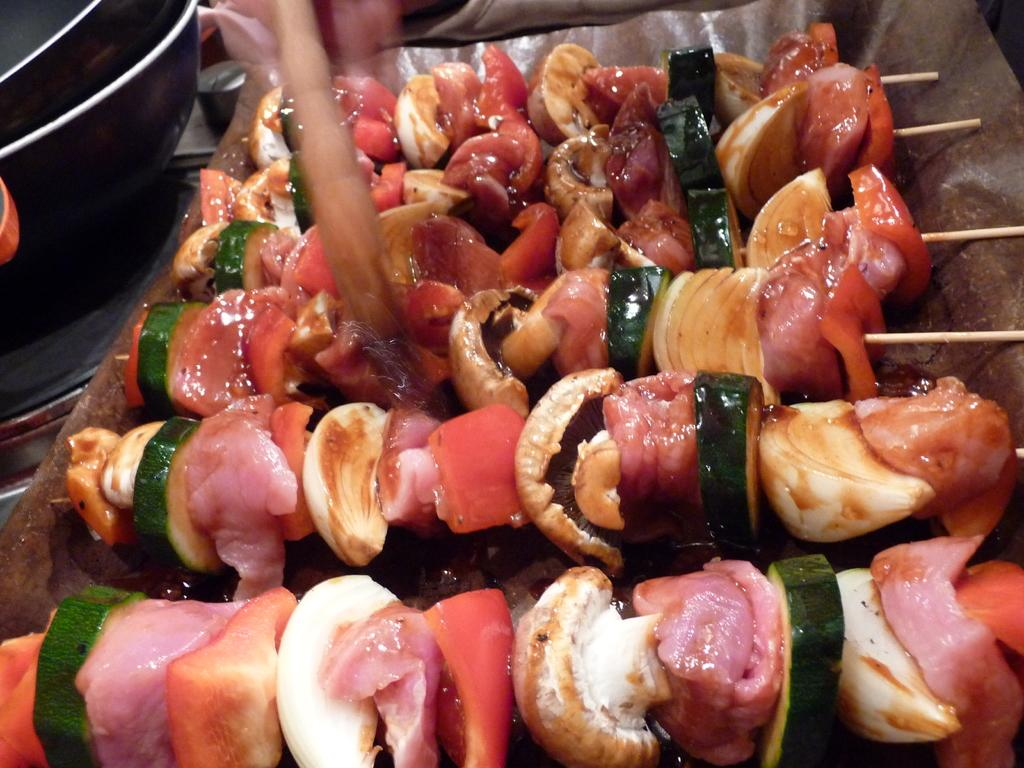What is the main subject in the center of the image? There is food in the center of the image. What can be seen on the left side of the image? There are black objects on the left side of the image. What color is the crayon used to draw on the food in the image? There is no crayon present in the image, and therefore no color can be determined. 